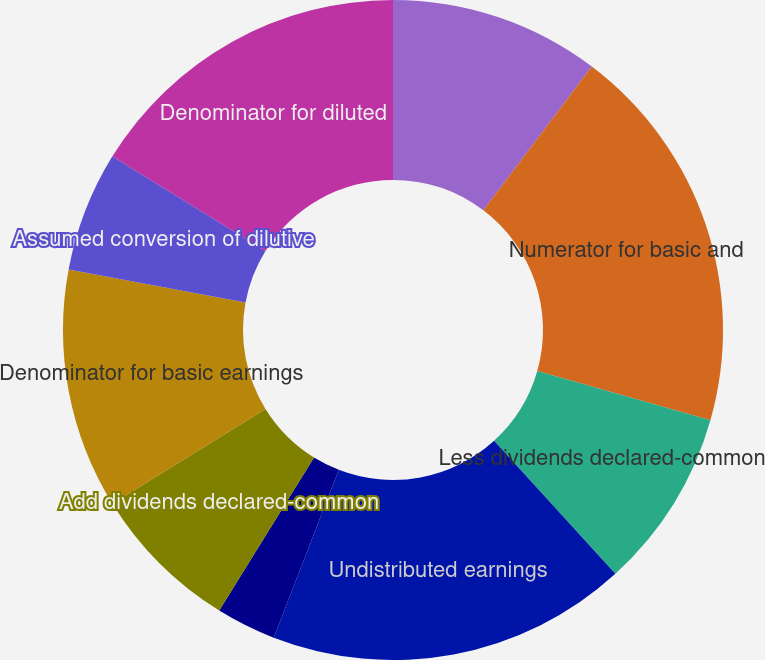Convert chart to OTSL. <chart><loc_0><loc_0><loc_500><loc_500><pie_chart><fcel>In thousands except per share<fcel>Numerator for basic and<fcel>Less dividends declared-common<fcel>Undistributed earnings<fcel>Percentage allocated to common<fcel>Add dividends declared-common<fcel>Denominator for basic earnings<fcel>Assumed conversion of dilutive<fcel>Denominator for diluted<nl><fcel>10.29%<fcel>19.12%<fcel>8.82%<fcel>17.65%<fcel>2.94%<fcel>7.35%<fcel>11.76%<fcel>5.88%<fcel>16.18%<nl></chart> 